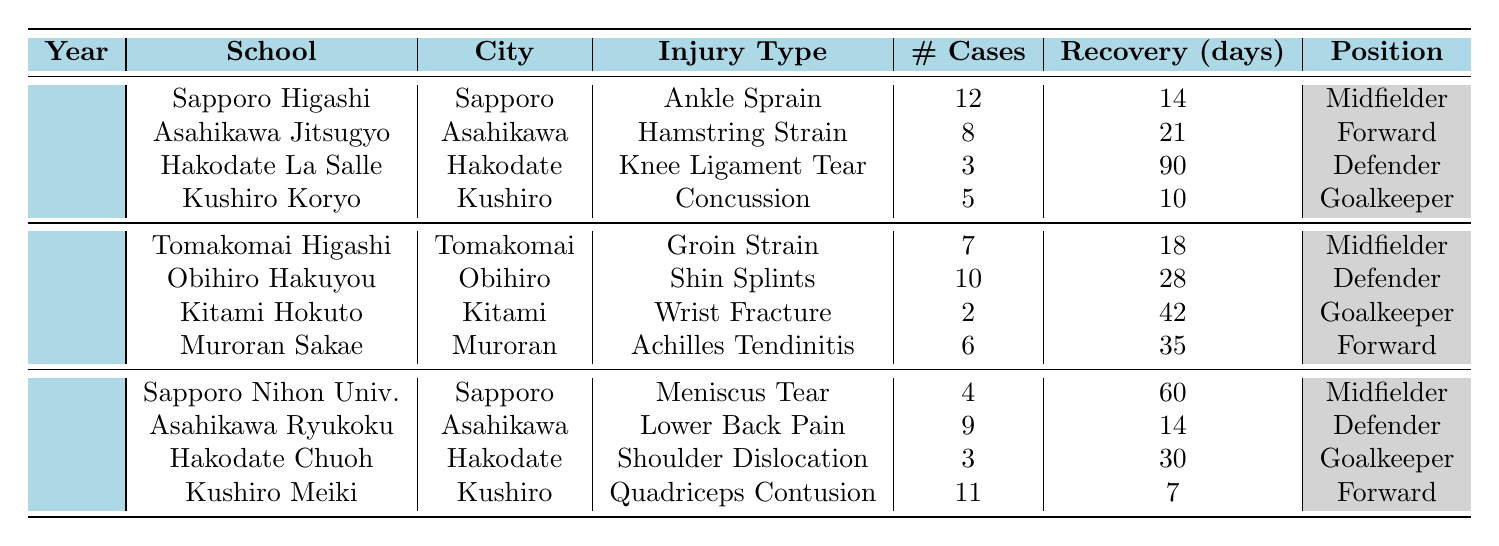How many injury cases were reported in 2020? The table shows four entries for 2020. The number of cases reported are 12, 8, 3, and 5. Summing these gives 12 + 8 + 3 + 5 = 28.
Answer: 28 What is the recovery time for a Knee Ligament Tear? In the table, under the entry for "Hakodate La Salle High School" in 2020, the recovery time for a Knee Ligament Tear is listed as 90 days.
Answer: 90 days Which position is most affected by Shin Splints? The table indicates that the position most affected by Shin Splints in 2021, from "Obihiro Hakuyou High School", is "Defender".
Answer: Defender What was the total number of cases for injuries reported in 2021? There are four entries for 2021 with cases of 7, 10, 2, and 6. Adding these values gives 7 + 10 + 2 + 6 = 25.
Answer: 25 Is there any injury type recorded for the Goalkeeper position in 2022? In the table, "Hakodate Chuoh High School" reports a Shoulder Dislocation as an injury for a Goalkeeper in 2022. Therefore, yes, there is an injury type recorded for the Goalkeeper position.
Answer: Yes What is the average recovery time for injuries reported in 2020? The recovery times for 2020 are 14, 21, 90, and 10 days. The average is calculated by summing these values (14 + 21 + 90 + 10 = 135) and dividing by 4 (135 / 4 = 33.75).
Answer: 33.75 days In which city was the most injury cases reported in 2022? Looking at the data for 2022, we can see the cases reported as follows: 4 in Sapporo, 9 in Asahikawa, 3 in Hakodate, and 11 in Kushiro. The highest is 11 cases in Kushiro.
Answer: Kushiro What is the difference in average recovery time between Ankle Sprain and Quadriceps Contusion? The average recovery time for Ankle Sprain in 2020 is 14 days, while for Quadriceps Contusion reported in 2022, it’s 7 days. The difference is 14 - 7 = 7 days.
Answer: 7 days Which school had the fewest injury cases in 2021? In 2021, the entries indicate the cases are 7, 10, 2, and 6. The smallest number is 2, reported by "Kitami Hokuto High School".
Answer: Kitami Hokuto High School Which injury has the longest average recovery time across all years? Reviewing the recovery times presented, the longest recovery time belongs to Knee Ligament Tear with 90 days from 2020.
Answer: Knee Ligament Tear 